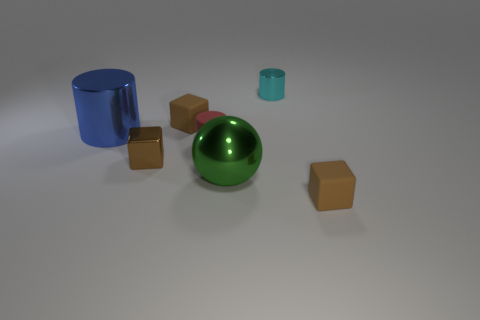There is a small object that is both behind the big cylinder and right of the red matte thing; what material is it made of?
Provide a short and direct response. Metal. Is there a object that has the same size as the metallic cube?
Offer a terse response. Yes. There is a cyan thing that is the same size as the brown metal thing; what material is it?
Offer a very short reply. Metal. There is a small metallic block; what number of small cyan objects are behind it?
Offer a terse response. 1. Is the shape of the thing that is on the left side of the small metallic block the same as  the red thing?
Give a very brief answer. Yes. Is there a big blue thing of the same shape as the red matte thing?
Offer a very short reply. Yes. What shape is the large metal thing to the right of the tiny red object that is to the left of the big ball?
Ensure brevity in your answer.  Sphere. What number of brown things are made of the same material as the blue cylinder?
Offer a very short reply. 1. There is a tiny cylinder that is the same material as the big blue cylinder; what color is it?
Provide a succinct answer. Cyan. What size is the metallic cylinder that is to the left of the brown block behind the large shiny thing that is to the left of the small brown metallic object?
Make the answer very short. Large. 